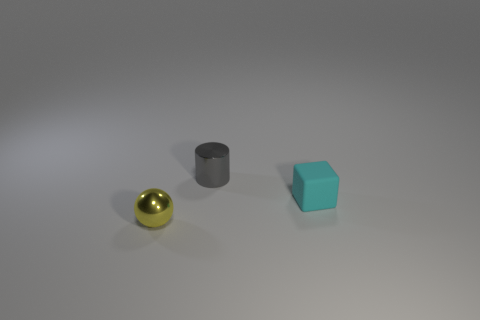Is there anything else that is the same material as the small block?
Provide a succinct answer. No. How many spheres are the same size as the cyan matte block?
Provide a succinct answer. 1. Is the number of objects that are to the left of the yellow metallic thing the same as the number of shiny objects that are behind the small cyan matte thing?
Offer a terse response. No. Does the yellow thing have the same material as the cyan thing?
Offer a terse response. No. There is a small metallic thing that is behind the yellow object; is there a small object that is on the left side of it?
Offer a very short reply. Yes. What is the material of the thing that is to the right of the thing that is behind the cyan cube?
Offer a very short reply. Rubber. There is a gray object that is made of the same material as the yellow thing; what is its size?
Ensure brevity in your answer.  Small. Is the size of the shiny object behind the yellow metal ball the same as the small cyan rubber block?
Your answer should be very brief. Yes. There is a metal thing behind the rubber thing that is in front of the object behind the cyan block; what shape is it?
Offer a terse response. Cylinder. How many things are tiny cubes or small rubber cubes in front of the tiny gray metallic cylinder?
Provide a succinct answer. 1. 